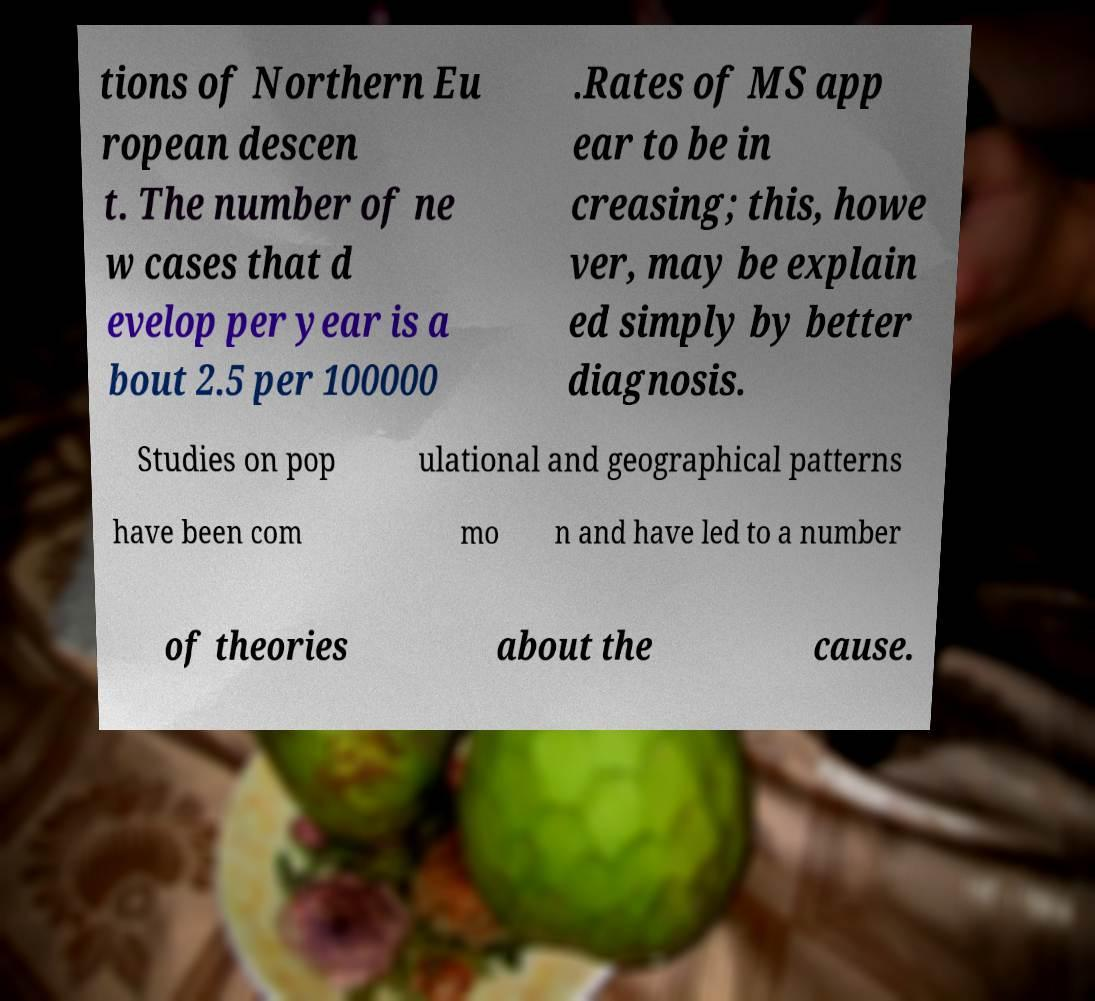What messages or text are displayed in this image? I need them in a readable, typed format. tions of Northern Eu ropean descen t. The number of ne w cases that d evelop per year is a bout 2.5 per 100000 .Rates of MS app ear to be in creasing; this, howe ver, may be explain ed simply by better diagnosis. Studies on pop ulational and geographical patterns have been com mo n and have led to a number of theories about the cause. 